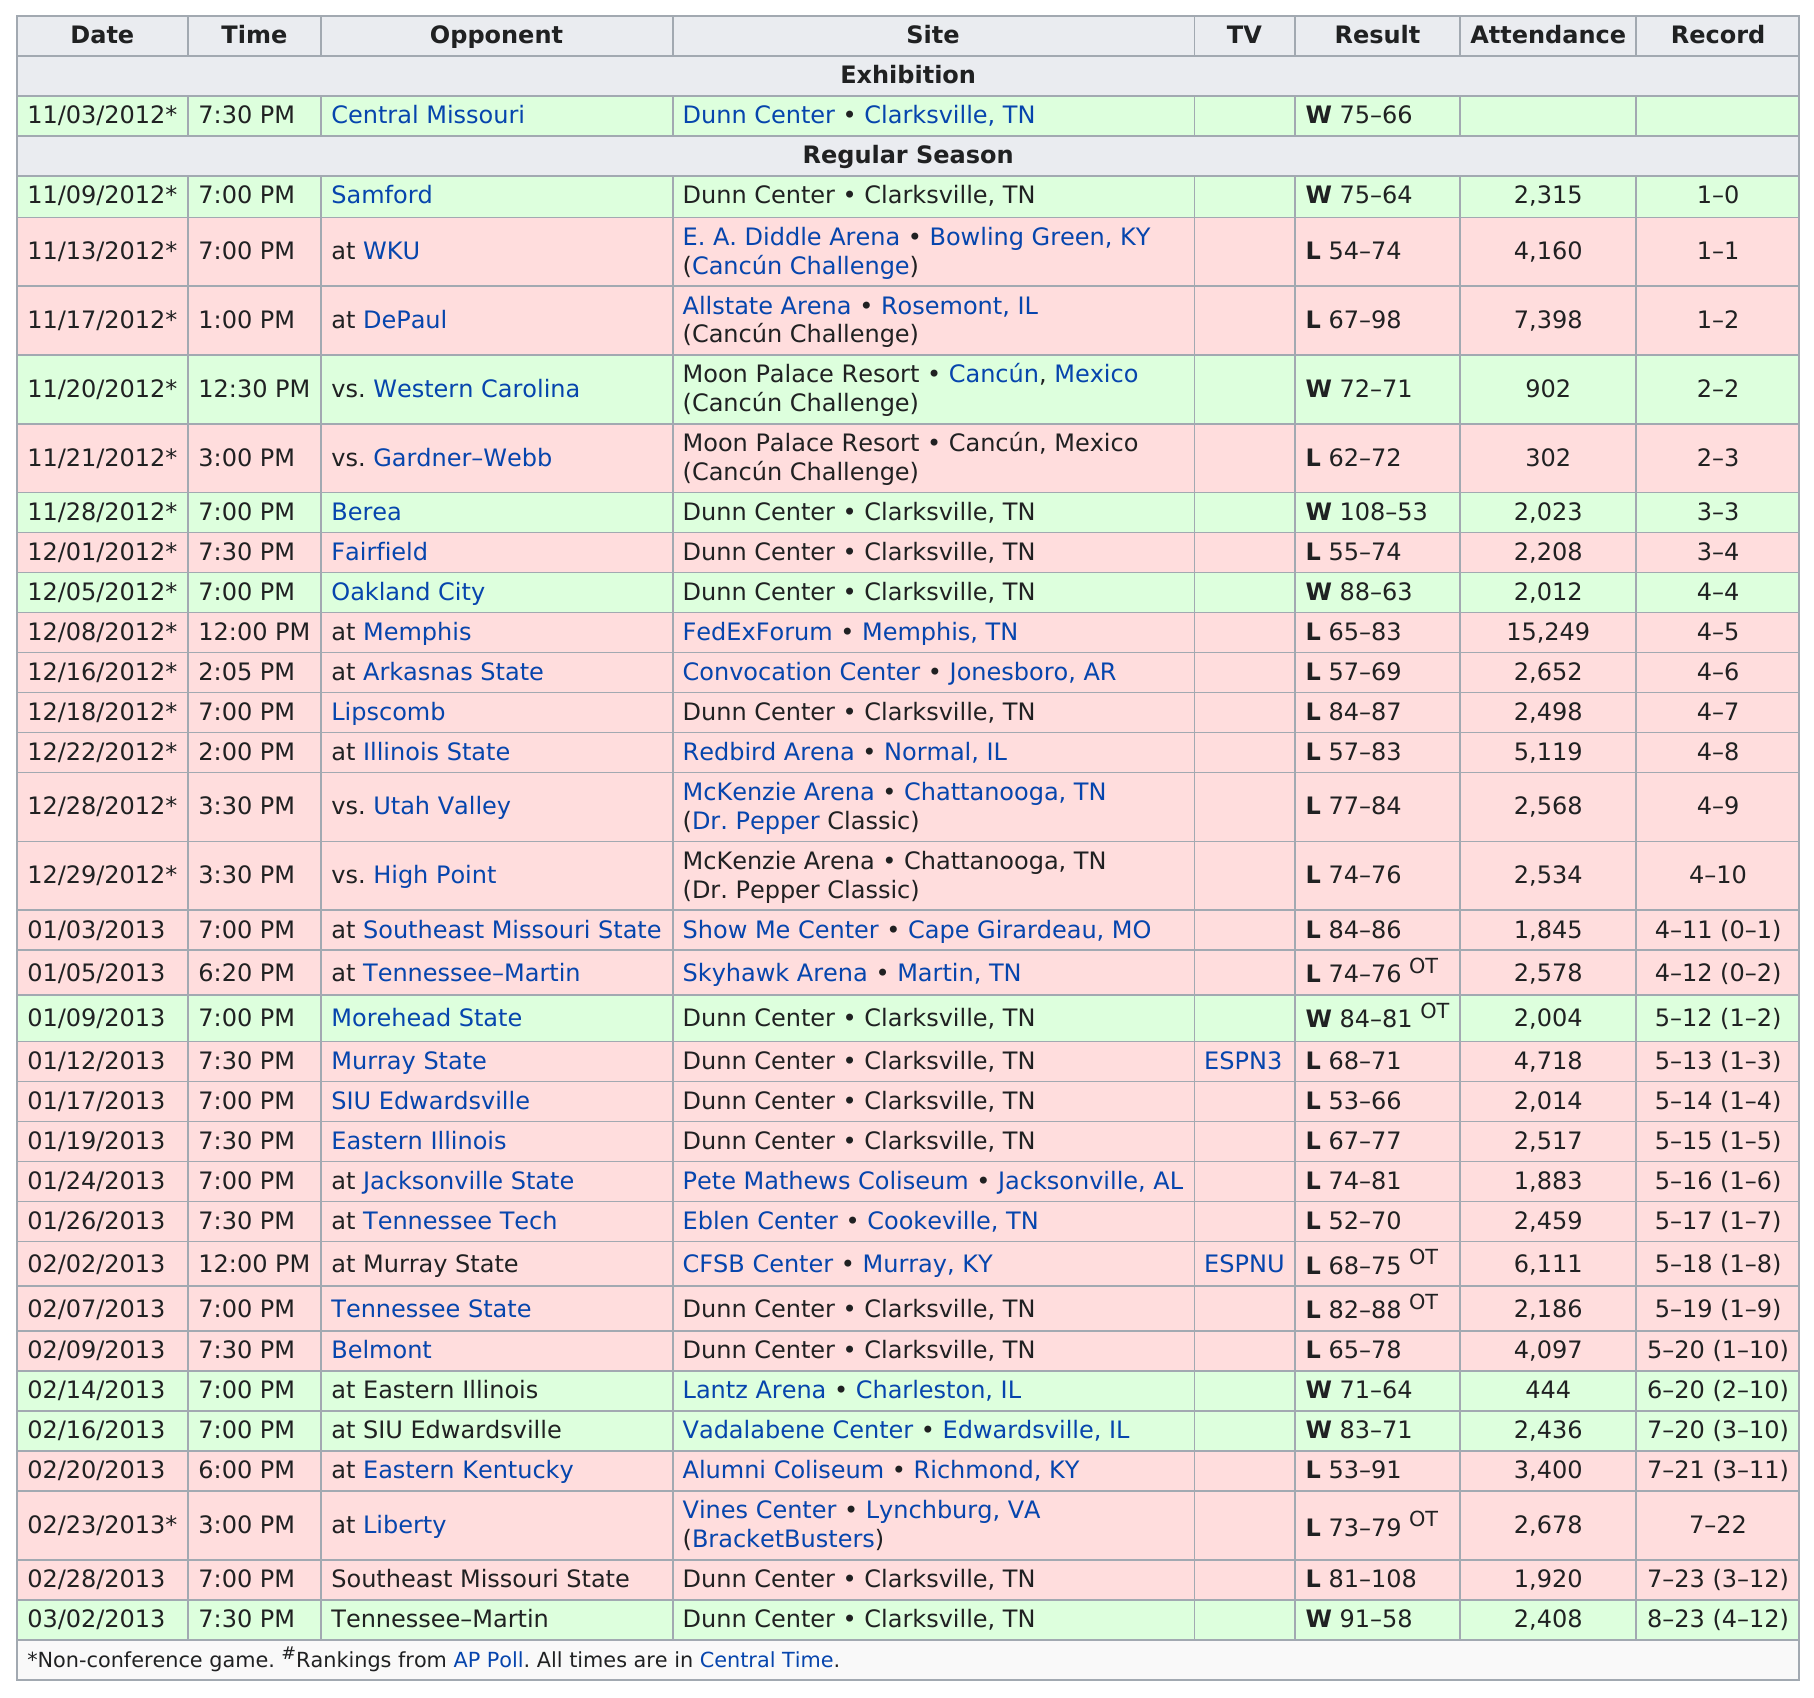Highlight a few significant elements in this photo. It is unclear which game, 11/28 or 12/08, had a larger attendance. The date of the game is 12/08/2012*. In how many contests was there no television coverage? There were 30 such contests. In the 2012-2013 season, the Austin Peay State Governors basketball team won a total of 9 games. The date of November 21, 2012 had the least number of people in attendance. On 11/28/2012, a total of 2,023 people attended the game. 